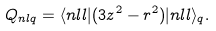Convert formula to latex. <formula><loc_0><loc_0><loc_500><loc_500>Q _ { n l q } = \langle n l l | ( 3 z ^ { 2 } - r ^ { 2 } ) | n l l \rangle _ { q } .</formula> 